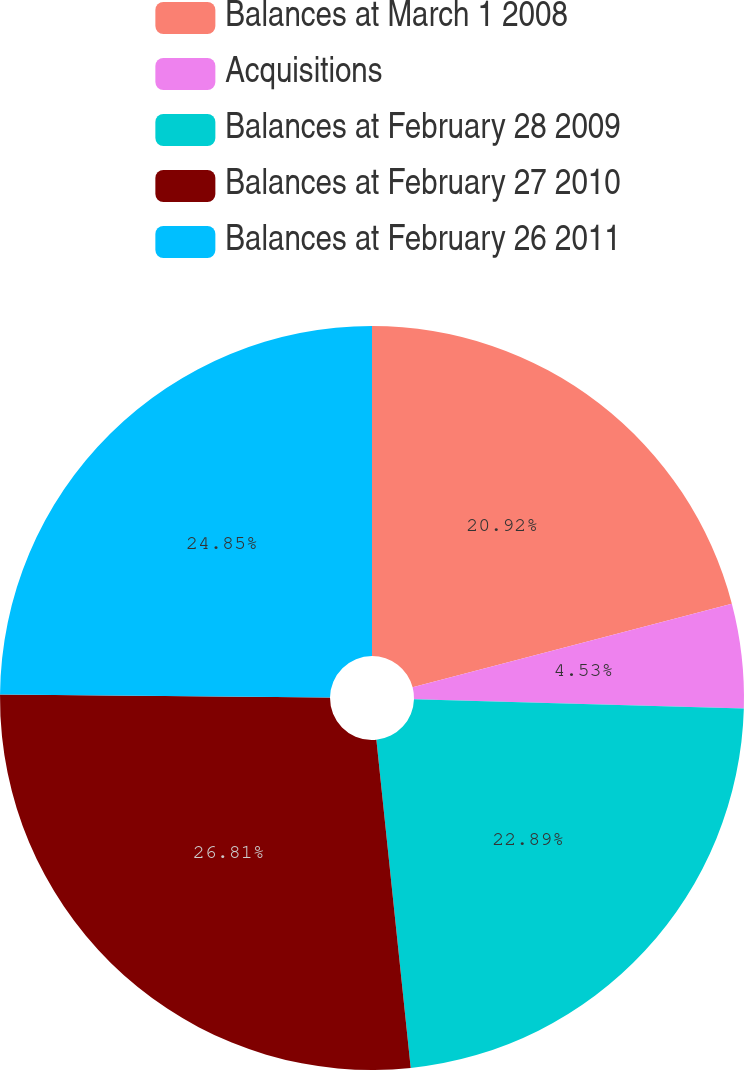<chart> <loc_0><loc_0><loc_500><loc_500><pie_chart><fcel>Balances at March 1 2008<fcel>Acquisitions<fcel>Balances at February 28 2009<fcel>Balances at February 27 2010<fcel>Balances at February 26 2011<nl><fcel>20.92%<fcel>4.53%<fcel>22.89%<fcel>26.81%<fcel>24.85%<nl></chart> 